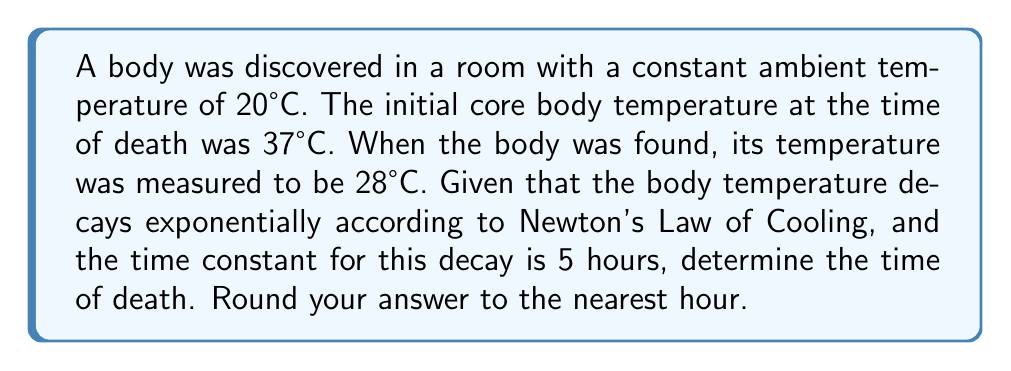Give your solution to this math problem. Let's approach this step-by-step using Newton's Law of Cooling:

1) The general form of Newton's Law of Cooling is:

   $$T(t) = T_a + (T_0 - T_a)e^{-kt}$$

   Where:
   $T(t)$ is the temperature at time $t$
   $T_a$ is the ambient temperature
   $T_0$ is the initial temperature
   $k$ is the cooling constant

2) We're given:
   $T_a = 20°C$
   $T_0 = 37°C$
   $T(t) = 28°C$
   Time constant $\tau = 5$ hours

3) The cooling constant $k$ is the inverse of the time constant:
   $$k = \frac{1}{\tau} = \frac{1}{5} = 0.2$$

4) Substituting these values into the equation:

   $$28 = 20 + (37 - 20)e^{-0.2t}$$

5) Simplifying:
   $$8 = 17e^{-0.2t}$$

6) Dividing both sides by 17:
   $$\frac{8}{17} = e^{-0.2t}$$

7) Taking the natural log of both sides:
   $$\ln(\frac{8}{17}) = -0.2t$$

8) Solving for $t$:
   $$t = -\frac{\ln(\frac{8}{17})}{0.2} \approx 3.76$$

9) Rounding to the nearest hour:
   $t \approx 4$ hours

Therefore, the estimated time of death is approximately 4 hours before the body was found.
Answer: 4 hours 